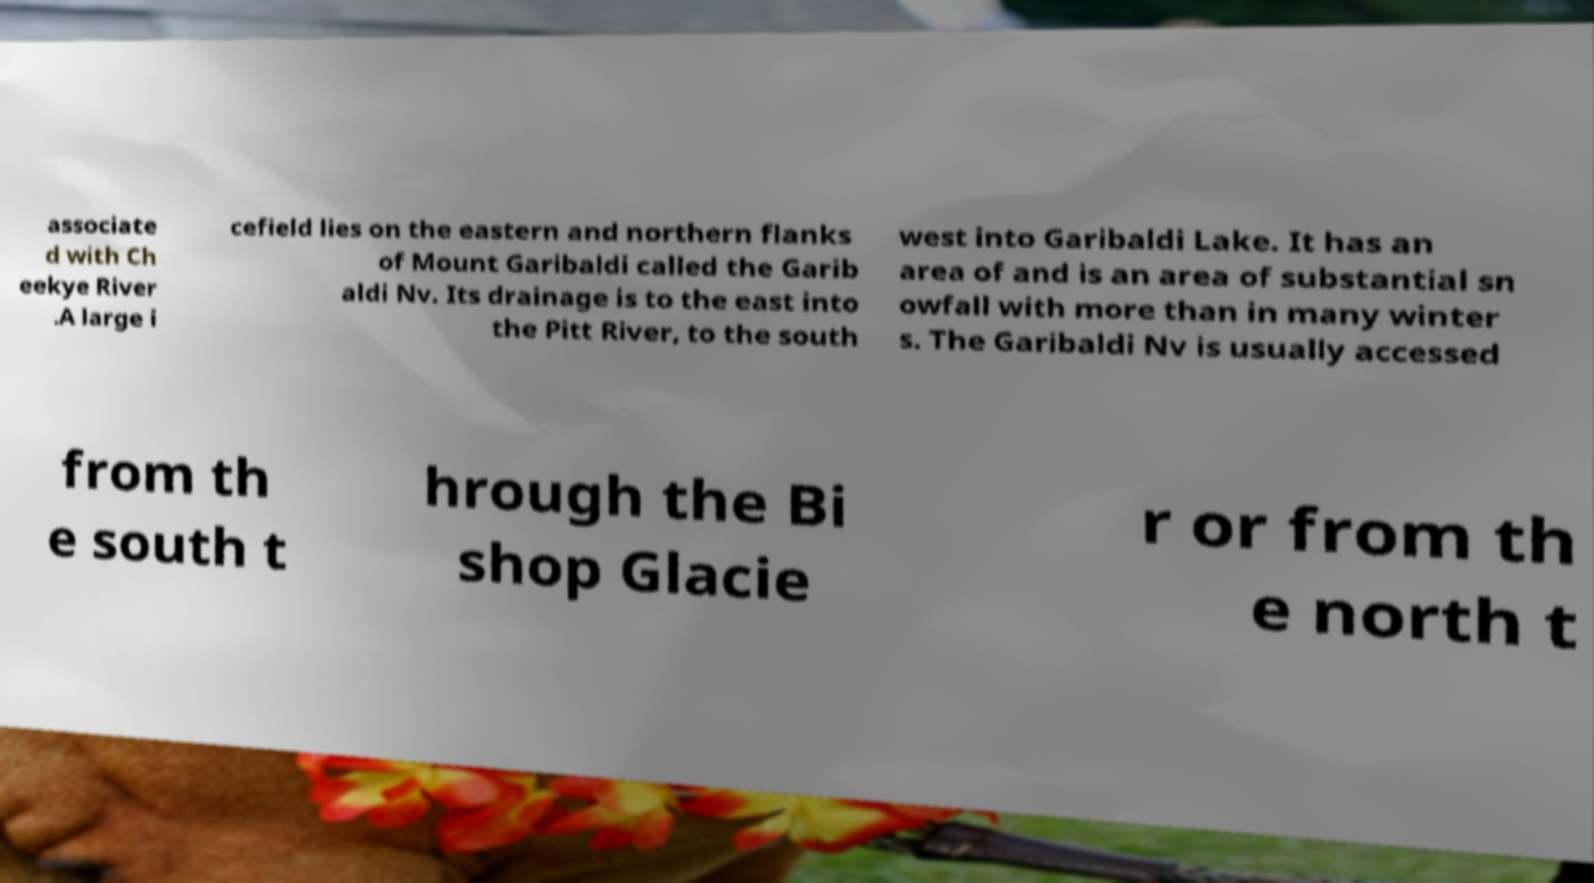Could you assist in decoding the text presented in this image and type it out clearly? associate d with Ch eekye River .A large i cefield lies on the eastern and northern flanks of Mount Garibaldi called the Garib aldi Nv. Its drainage is to the east into the Pitt River, to the south west into Garibaldi Lake. It has an area of and is an area of substantial sn owfall with more than in many winter s. The Garibaldi Nv is usually accessed from th e south t hrough the Bi shop Glacie r or from th e north t 